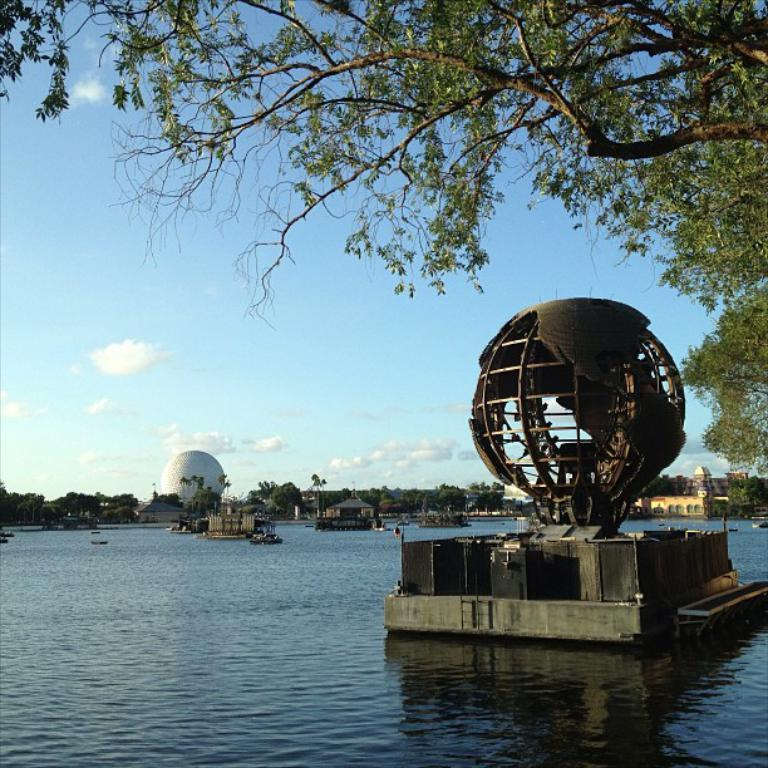What is the primary element present in the image? There is water in the image. What can be found within the water? There are objects in the water. What is visible in the background of the image? The sky is visible in the image, and there are clouds in the sky. What type of natural vegetation can be seen in the image? There are trees in the image. What type of man-made structures are present in the image? There are buildings in the image. How many pencils can be seen floating in the water in the image? There are no pencils present in the image; it features water with objects in it. What type of frogs can be seen swimming in the water in the image? There are no frogs present in the image; it features water with objects in it. 